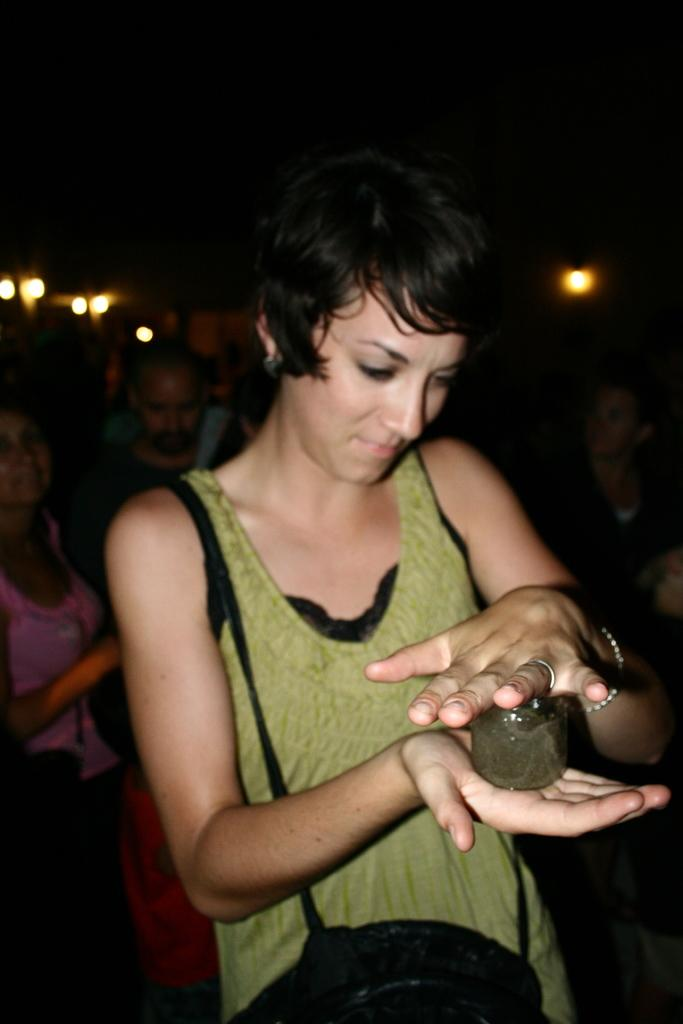Who is the main subject in the image? There is a woman in the image. What is the woman holding in the image? The woman is holding a container. What is the woman wearing in the image? The woman is wearing a bag. Can you describe the background of the image? There are people visible in the background, and the background has a dark view. What else can be seen in the image? There are lights in the image. What type of pie is being prepared on the stone in the image? There is no pie or stone present in the image. 